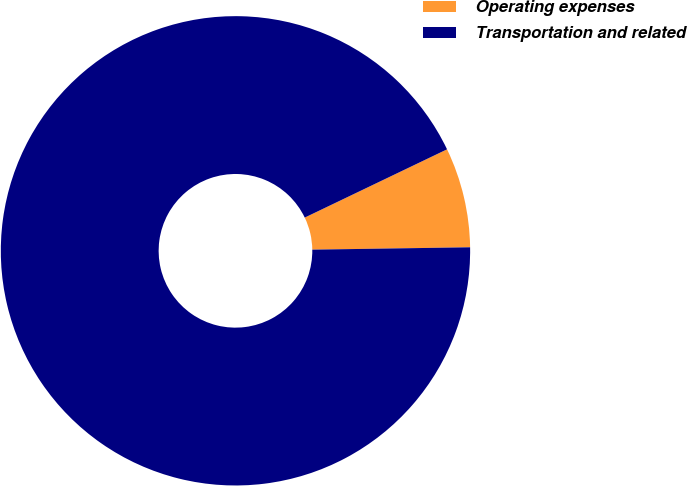Convert chart to OTSL. <chart><loc_0><loc_0><loc_500><loc_500><pie_chart><fcel>Operating expenses<fcel>Transportation and related<nl><fcel>6.88%<fcel>93.12%<nl></chart> 